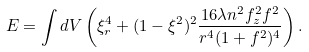<formula> <loc_0><loc_0><loc_500><loc_500>E = \int d V \left ( \xi _ { r } ^ { 4 } + ( 1 - \xi ^ { 2 } ) ^ { 2 } \frac { 1 6 \lambda n ^ { 2 } f _ { z } ^ { 2 } f ^ { 2 } } { r ^ { 4 } ( 1 + f ^ { 2 } ) ^ { 4 } } \right ) .</formula> 